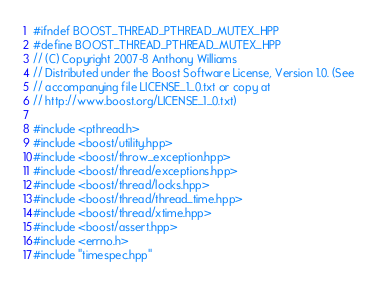<code> <loc_0><loc_0><loc_500><loc_500><_C++_>#ifndef BOOST_THREAD_PTHREAD_MUTEX_HPP
#define BOOST_THREAD_PTHREAD_MUTEX_HPP
// (C) Copyright 2007-8 Anthony Williams
// Distributed under the Boost Software License, Version 1.0. (See
// accompanying file LICENSE_1_0.txt or copy at
// http://www.boost.org/LICENSE_1_0.txt)

#include <pthread.h>
#include <boost/utility.hpp>
#include <boost/throw_exception.hpp>
#include <boost/thread/exceptions.hpp>
#include <boost/thread/locks.hpp>
#include <boost/thread/thread_time.hpp>
#include <boost/thread/xtime.hpp>
#include <boost/assert.hpp>
#include <errno.h>
#include "timespec.hpp"</code> 